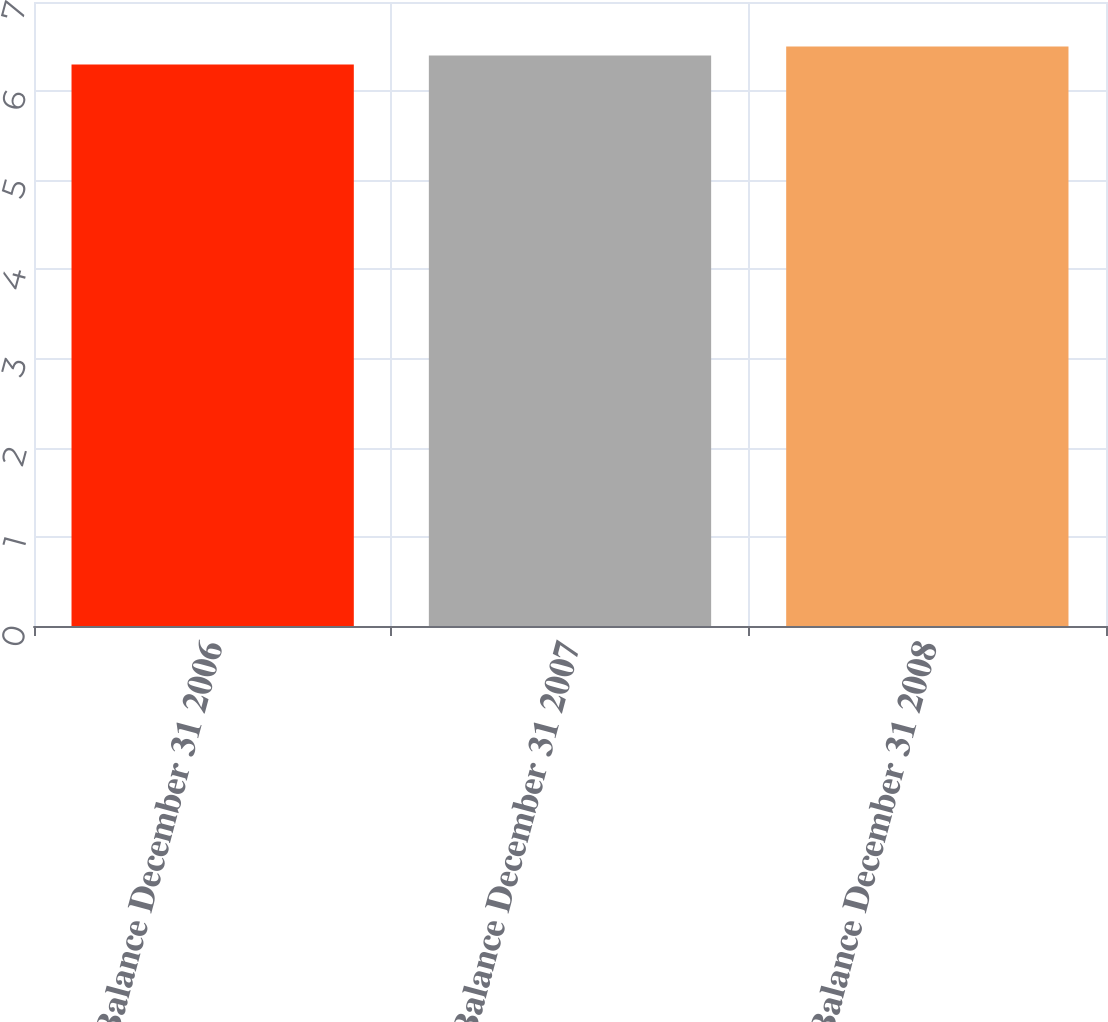<chart> <loc_0><loc_0><loc_500><loc_500><bar_chart><fcel>Balance December 31 2006<fcel>Balance December 31 2007<fcel>Balance December 31 2008<nl><fcel>6.3<fcel>6.4<fcel>6.5<nl></chart> 